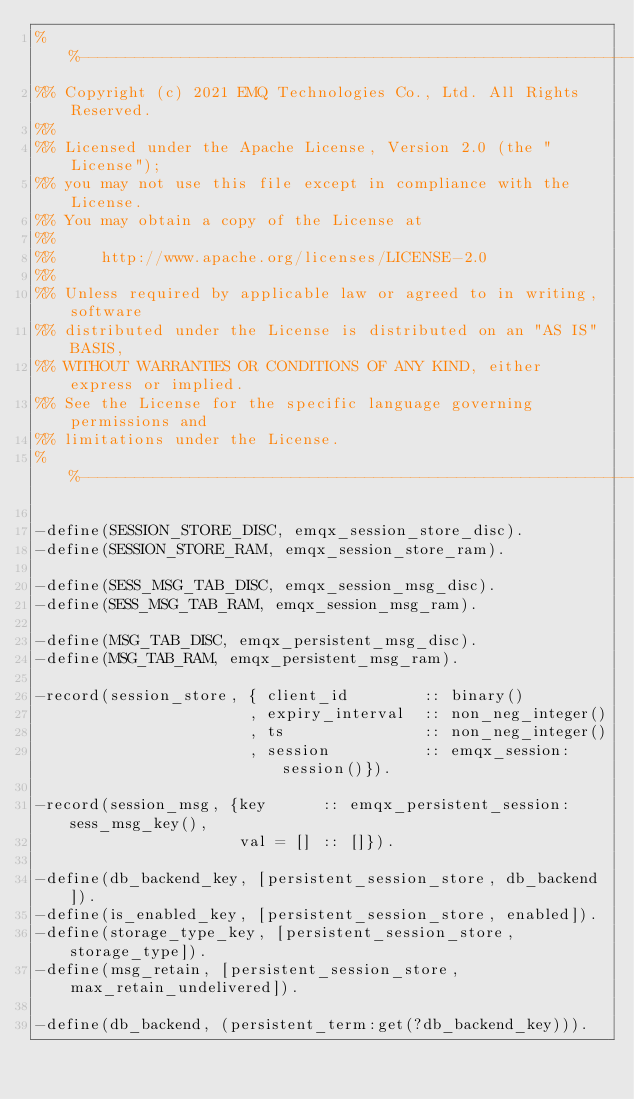Convert code to text. <code><loc_0><loc_0><loc_500><loc_500><_Erlang_>%%--------------------------------------------------------------------
%% Copyright (c) 2021 EMQ Technologies Co., Ltd. All Rights Reserved.
%%
%% Licensed under the Apache License, Version 2.0 (the "License");
%% you may not use this file except in compliance with the License.
%% You may obtain a copy of the License at
%%
%%     http://www.apache.org/licenses/LICENSE-2.0
%%
%% Unless required by applicable law or agreed to in writing, software
%% distributed under the License is distributed on an "AS IS" BASIS,
%% WITHOUT WARRANTIES OR CONDITIONS OF ANY KIND, either express or implied.
%% See the License for the specific language governing permissions and
%% limitations under the License.
%%--------------------------------------------------------------------

-define(SESSION_STORE_DISC, emqx_session_store_disc).
-define(SESSION_STORE_RAM, emqx_session_store_ram).

-define(SESS_MSG_TAB_DISC, emqx_session_msg_disc).
-define(SESS_MSG_TAB_RAM, emqx_session_msg_ram).

-define(MSG_TAB_DISC, emqx_persistent_msg_disc).
-define(MSG_TAB_RAM, emqx_persistent_msg_ram).

-record(session_store, { client_id        :: binary()
                       , expiry_interval  :: non_neg_integer()
                       , ts               :: non_neg_integer()
                       , session          :: emqx_session:session()}).

-record(session_msg, {key      :: emqx_persistent_session:sess_msg_key(),
                      val = [] :: []}).

-define(db_backend_key, [persistent_session_store, db_backend]).
-define(is_enabled_key, [persistent_session_store, enabled]).
-define(storage_type_key, [persistent_session_store, storage_type]).
-define(msg_retain, [persistent_session_store, max_retain_undelivered]).

-define(db_backend, (persistent_term:get(?db_backend_key))).
</code> 